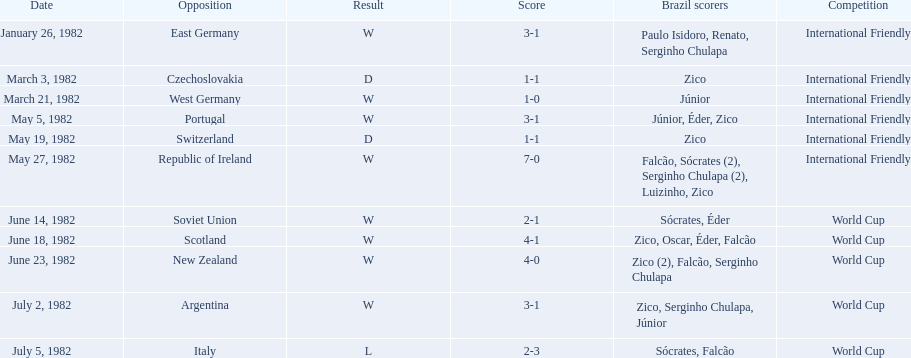What date is positioned at the highest point of the list? January 26, 1982. 